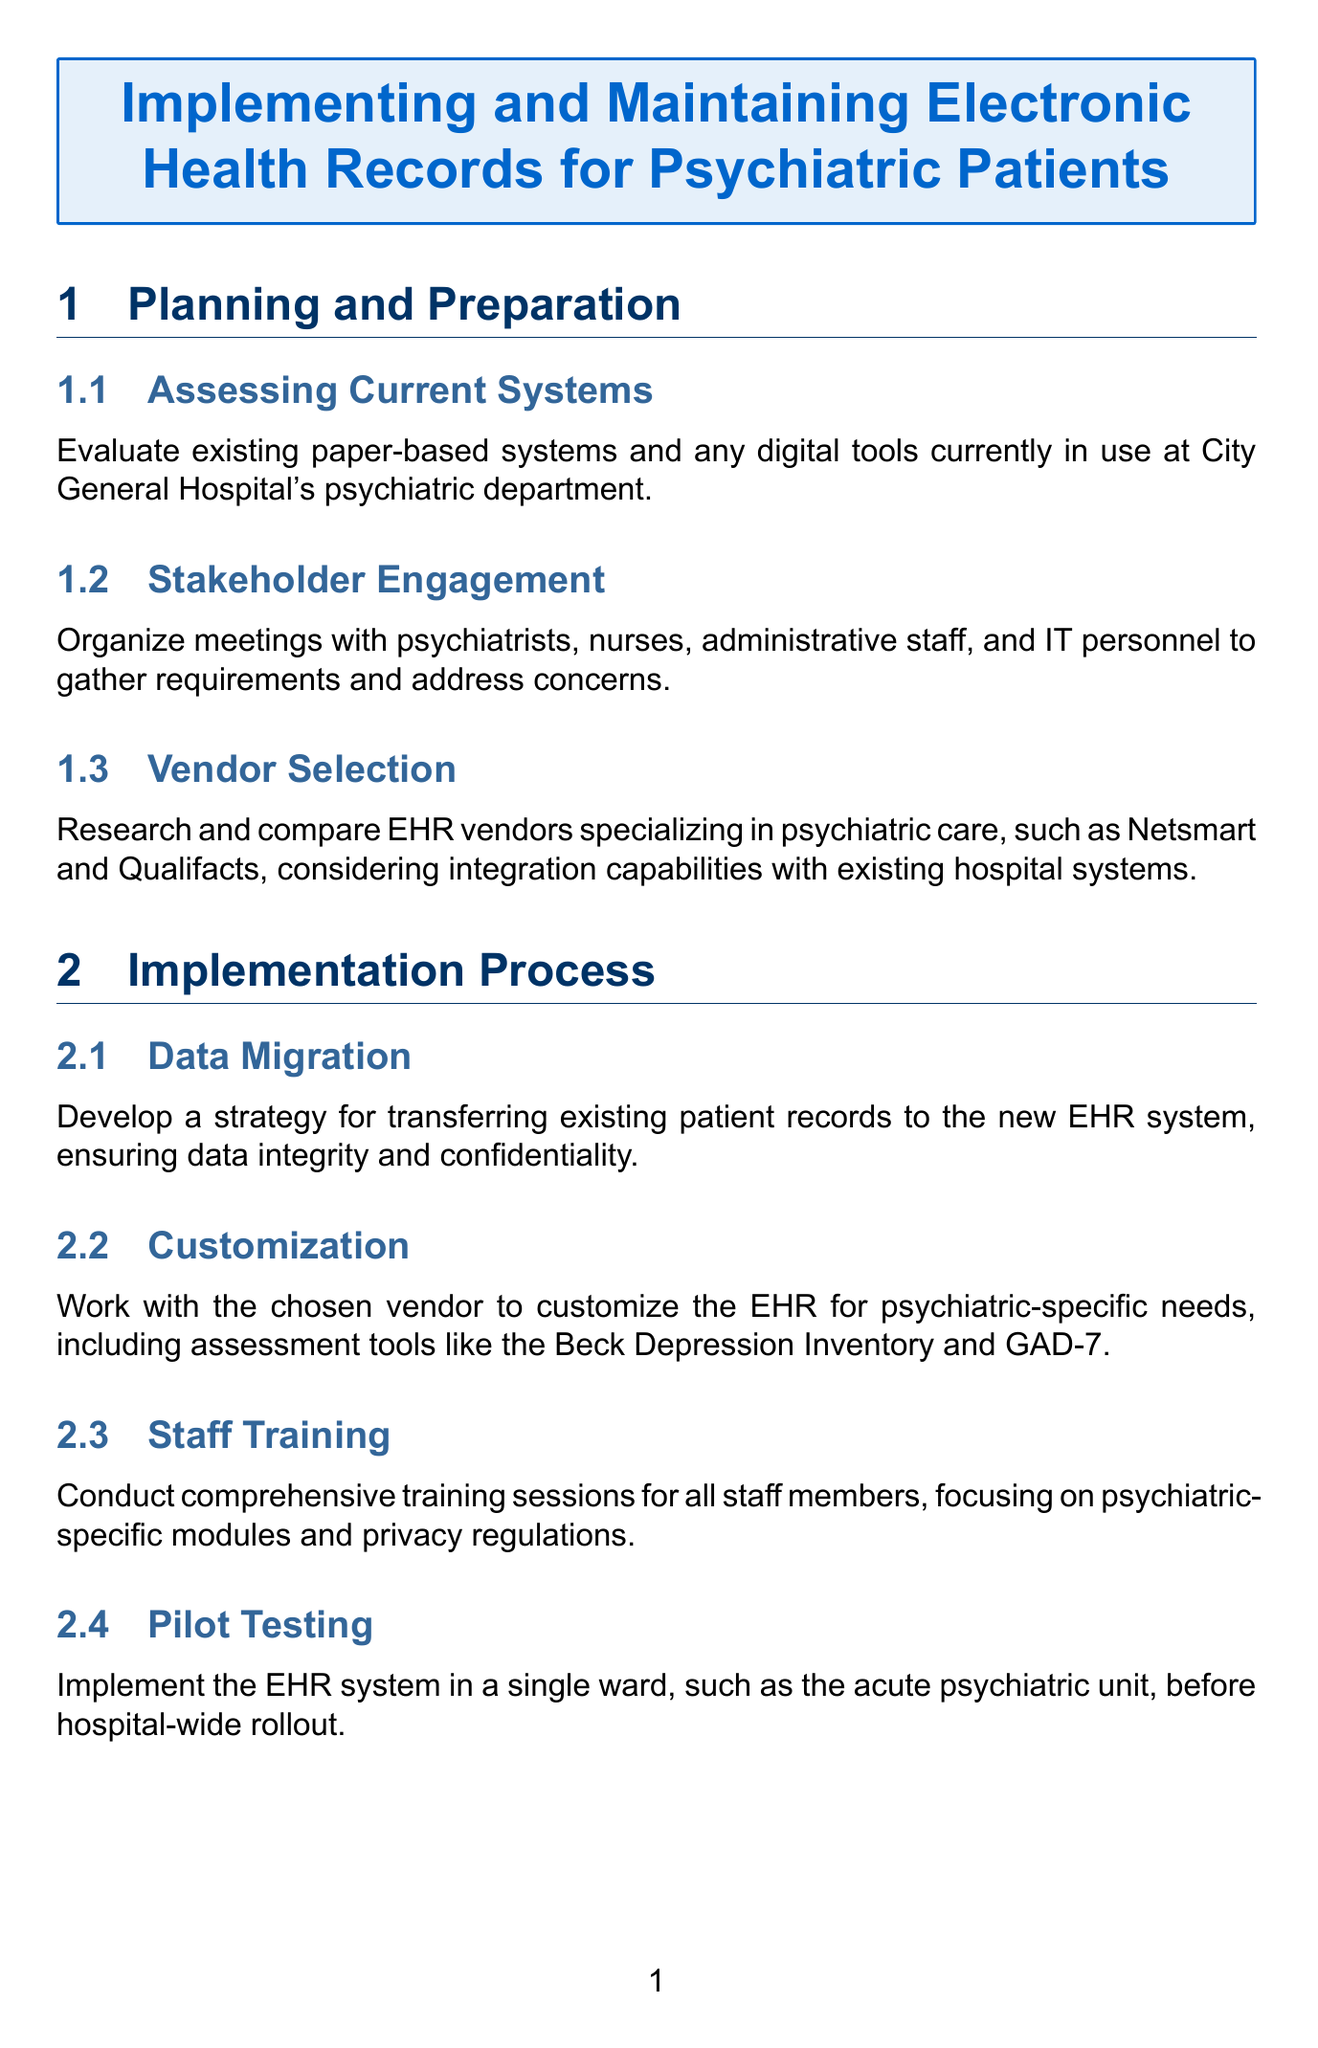what is the title of the document? The title of the document is provided at the beginning, indicating its main subject matter regarding electronic health records specific to psychiatric patients.
Answer: Implementing and Maintaining Electronic Health Records for Psychiatric Patients how many sections are there in the document? The document is divided into multiple main sections, and counting them provides the total number of sections.
Answer: 6 what is one of the vendor names mentioned for EHR systems? The document lists specific EHR vendors that specialize in psychiatric care under the vendor selection subsection.
Answer: Netsmart which assessment tool is included for customization of the EHR? The customization subsection mentions specific assessment tools that are relevant to psychiatric care that should be included in the EHR customization.
Answer: Beck Depression Inventory what should be incorporated in the risk assessment? The psychiatric-specific considerations section includes a mention of standardized tools that should be integrated into the risk assessment strategy.
Answer: Columbia-Suicide Severity Rating Scale what is a key aspect of HIPAA compliance in the document? The compliance and reporting section discusses the importance of privacy related to mental health records, highlighting the core requirements for HIPAA compliance.
Answer: privacy of mental health records which section discusses ongoing education for staff? The maintenance and optimization section contains a mention of continuous training, focusing on the importance of ongoing staff education regarding the EHR system.
Answer: Continuous Training what type of information is suggested to integrate with the hospital's laboratory information system? The integration and interoperability section specifies the types of medical information that should seamlessly connect with the hospital’s systems.
Answer: relevant test results what is assessed during performance monitoring? The document details that specific aspects of the EHR system’s operation are evaluated regularly and outlines what is monitored.
Answer: system performance 